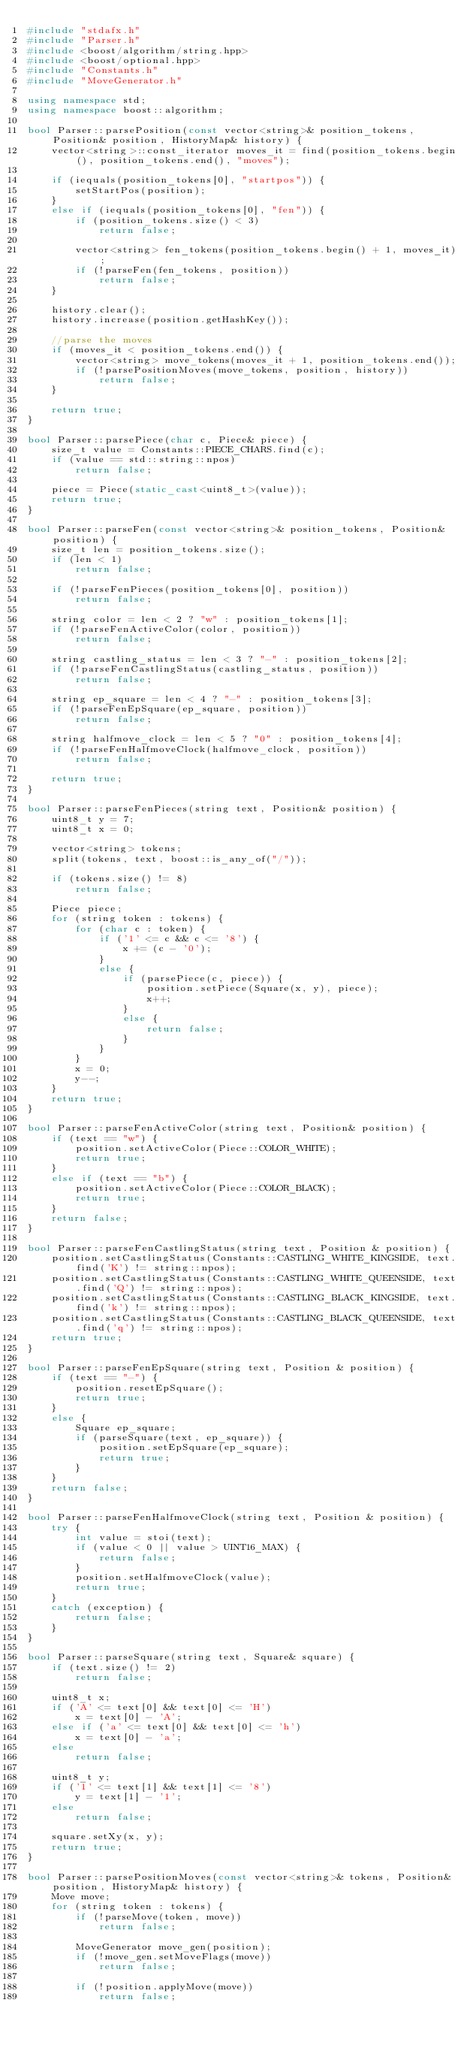Convert code to text. <code><loc_0><loc_0><loc_500><loc_500><_C++_>#include "stdafx.h"
#include "Parser.h"
#include <boost/algorithm/string.hpp>
#include <boost/optional.hpp>
#include "Constants.h"
#include "MoveGenerator.h"

using namespace std;
using namespace boost::algorithm;

bool Parser::parsePosition(const vector<string>& position_tokens, Position& position, HistoryMap& history) {
	vector<string>::const_iterator moves_it = find(position_tokens.begin(), position_tokens.end(), "moves");

	if (iequals(position_tokens[0], "startpos")) {
		setStartPos(position);
	}
	else if (iequals(position_tokens[0], "fen")) {
		if (position_tokens.size() < 3)
			return false;

		vector<string> fen_tokens(position_tokens.begin() + 1, moves_it);
		if (!parseFen(fen_tokens, position)) 
			return false;
	}

	history.clear();
	history.increase(position.getHashKey());

	//parse the moves
	if (moves_it < position_tokens.end()) {
		vector<string> move_tokens(moves_it + 1, position_tokens.end());
		if (!parsePositionMoves(move_tokens, position, history))
			return false;
	}

	return true;
}

bool Parser::parsePiece(char c, Piece& piece) {
	size_t value = Constants::PIECE_CHARS.find(c);
	if (value == std::string::npos)
		return false;

	piece = Piece(static_cast<uint8_t>(value));
	return true;
}

bool Parser::parseFen(const vector<string>& position_tokens, Position& position) {
	size_t len = position_tokens.size();
	if (len < 1)
		return false;

	if (!parseFenPieces(position_tokens[0], position))
		return false;

	string color = len < 2 ? "w" : position_tokens[1];
	if (!parseFenActiveColor(color, position))
		return false;

	string castling_status = len < 3 ? "-" : position_tokens[2];
	if (!parseFenCastlingStatus(castling_status, position))
		return false;

	string ep_square = len < 4 ? "-" : position_tokens[3];
	if (!parseFenEpSquare(ep_square, position))
		return false;

	string halfmove_clock = len < 5 ? "0" : position_tokens[4];
	if (!parseFenHalfmoveClock(halfmove_clock, position))
		return false;

	return true;
}

bool Parser::parseFenPieces(string text, Position& position) {
	uint8_t y = 7;
	uint8_t x = 0;

	vector<string> tokens;
	split(tokens, text, boost::is_any_of("/"));

	if (tokens.size() != 8)
		return false;

	Piece piece;
	for (string token : tokens) {
		for (char c : token) {
			if ('1' <= c && c <= '8') {
				x += (c - '0');
			}
			else {
				if (parsePiece(c, piece)) {
					position.setPiece(Square(x, y), piece);
					x++;
				}
				else {
					return false;
				}
			}
		}
		x = 0;
		y--;
	}
	return true;
}

bool Parser::parseFenActiveColor(string text, Position& position) {
	if (text == "w") {
		position.setActiveColor(Piece::COLOR_WHITE);
		return true;
	}
	else if (text == "b") {
		position.setActiveColor(Piece::COLOR_BLACK);
		return true;
	}
	return false;
}

bool Parser::parseFenCastlingStatus(string text, Position & position) {
	position.setCastlingStatus(Constants::CASTLING_WHITE_KINGSIDE, text.find('K') != string::npos);
	position.setCastlingStatus(Constants::CASTLING_WHITE_QUEENSIDE, text.find('Q') != string::npos);
	position.setCastlingStatus(Constants::CASTLING_BLACK_KINGSIDE, text.find('k') != string::npos);
	position.setCastlingStatus(Constants::CASTLING_BLACK_QUEENSIDE, text.find('q') != string::npos);
	return true;
}

bool Parser::parseFenEpSquare(string text, Position & position) {
	if (text == "-") {
		position.resetEpSquare();
		return true;
	}
	else {
		Square ep_square;
		if (parseSquare(text, ep_square)) {
			position.setEpSquare(ep_square);
			return true;
		}
	}
	return false;
}

bool Parser::parseFenHalfmoveClock(string text, Position & position) {
	try {
		int value = stoi(text);
		if (value < 0 || value > UINT16_MAX) {
			return false;
		}
		position.setHalfmoveClock(value);
		return true;
	}
	catch (exception) {
		return false;
	}
}

bool Parser::parseSquare(string text, Square& square) {
	if (text.size() != 2)
		return false;
	
	uint8_t x;
	if ('A' <= text[0] && text[0] <= 'H')
		x = text[0] - 'A';
	else if ('a' <= text[0] && text[0] <= 'h')
		x = text[0] - 'a';
	else
		return false;

	uint8_t y;
	if ('1' <= text[1] && text[1] <= '8')
		y = text[1] - '1';
	else
		return false;

	square.setXy(x, y);
	return true;
}

bool Parser::parsePositionMoves(const vector<string>& tokens, Position& position, HistoryMap& history) {
	Move move;
	for (string token : tokens) {
		if (!parseMove(token, move))
			return false;

		MoveGenerator move_gen(position);
		if (!move_gen.setMoveFlags(move))
			return false;

		if (!position.applyMove(move))
			return false;
</code> 